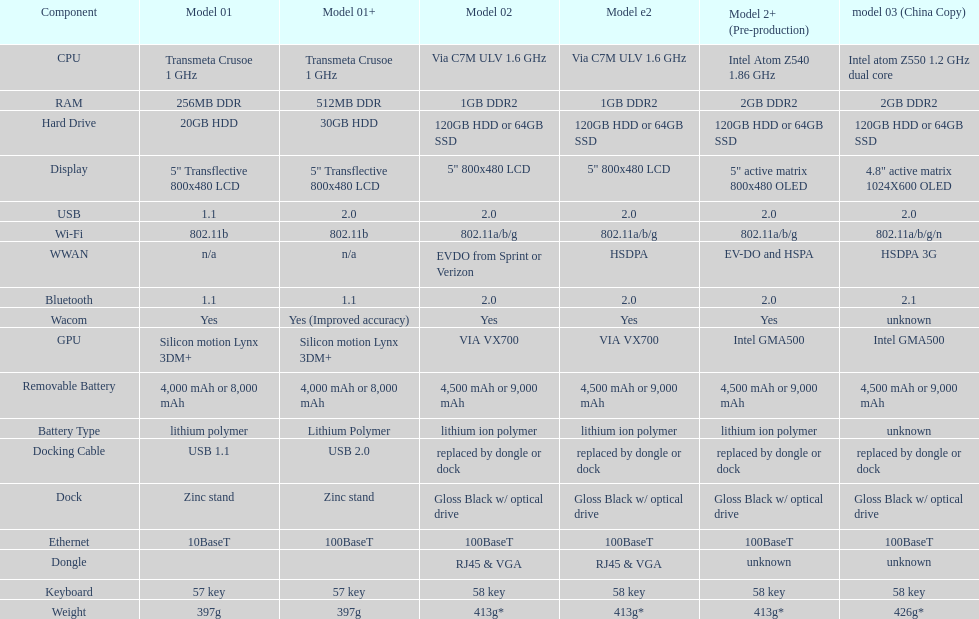How many devices feature a 2. 